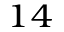<formula> <loc_0><loc_0><loc_500><loc_500>_ { 1 4 }</formula> 